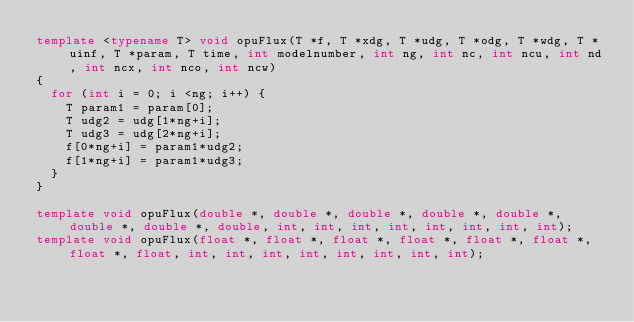<code> <loc_0><loc_0><loc_500><loc_500><_C++_>template <typename T> void opuFlux(T *f, T *xdg, T *udg, T *odg, T *wdg, T *uinf, T *param, T time, int modelnumber, int ng, int nc, int ncu, int nd, int ncx, int nco, int ncw)
{
	for (int i = 0; i <ng; i++) {
		T param1 = param[0];
		T udg2 = udg[1*ng+i];
		T udg3 = udg[2*ng+i];
		f[0*ng+i] = param1*udg2;
		f[1*ng+i] = param1*udg3;
	}
}

template void opuFlux(double *, double *, double *, double *, double *, double *, double *, double, int, int, int, int, int, int, int, int);
template void opuFlux(float *, float *, float *, float *, float *, float *, float *, float, int, int, int, int, int, int, int, int);
</code> 